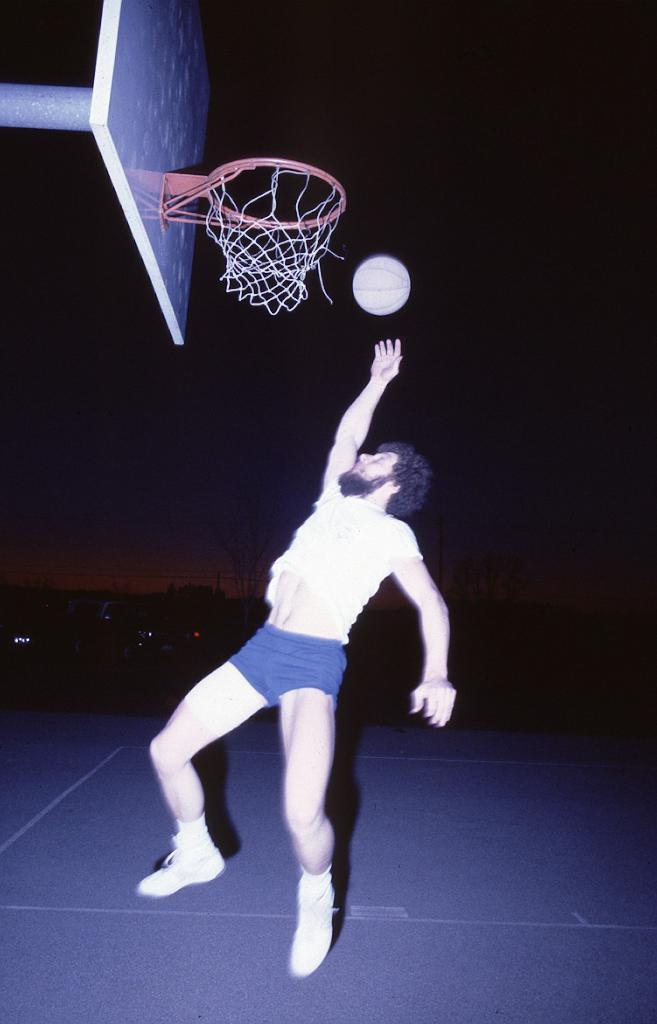What is the main subject of the image? There is a person in the image. What activity is the person engaged in? The person is playing basketball. Can you describe the background of the image? The background of the image is dark. What type of lunch is the person eating during the basketball game? There is no indication in the image that the person is eating lunch, so it cannot be determined from the picture. 